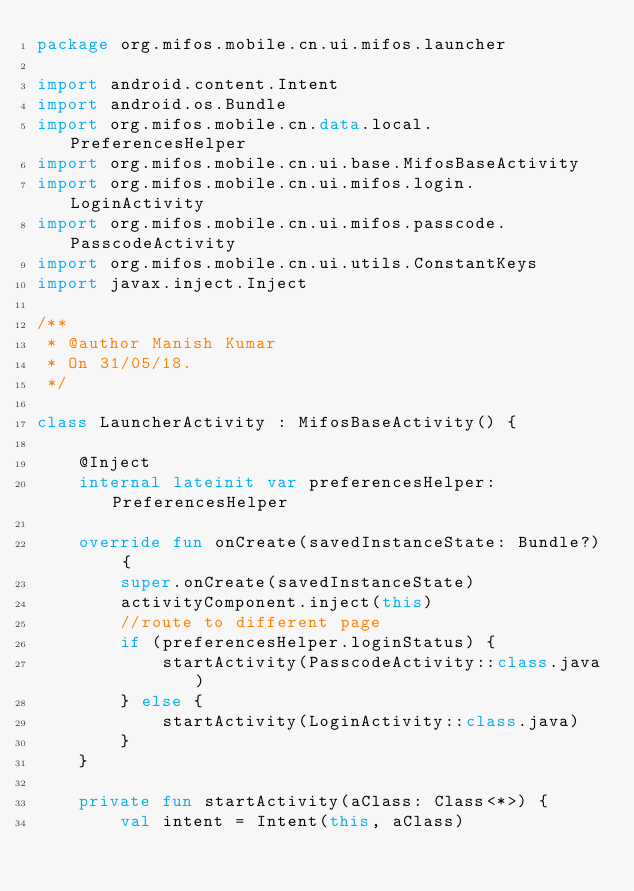Convert code to text. <code><loc_0><loc_0><loc_500><loc_500><_Kotlin_>package org.mifos.mobile.cn.ui.mifos.launcher

import android.content.Intent
import android.os.Bundle
import org.mifos.mobile.cn.data.local.PreferencesHelper
import org.mifos.mobile.cn.ui.base.MifosBaseActivity
import org.mifos.mobile.cn.ui.mifos.login.LoginActivity
import org.mifos.mobile.cn.ui.mifos.passcode.PasscodeActivity
import org.mifos.mobile.cn.ui.utils.ConstantKeys
import javax.inject.Inject

/**
 * @author Manish Kumar
 * On 31/05/18.
 */

class LauncherActivity : MifosBaseActivity() {

    @Inject
    internal lateinit var preferencesHelper: PreferencesHelper

    override fun onCreate(savedInstanceState: Bundle?) {
        super.onCreate(savedInstanceState)
        activityComponent.inject(this)
        //route to different page
        if (preferencesHelper.loginStatus) {
            startActivity(PasscodeActivity::class.java)
        } else {
            startActivity(LoginActivity::class.java)
        }
    }

    private fun startActivity(aClass: Class<*>) {
        val intent = Intent(this, aClass)</code> 